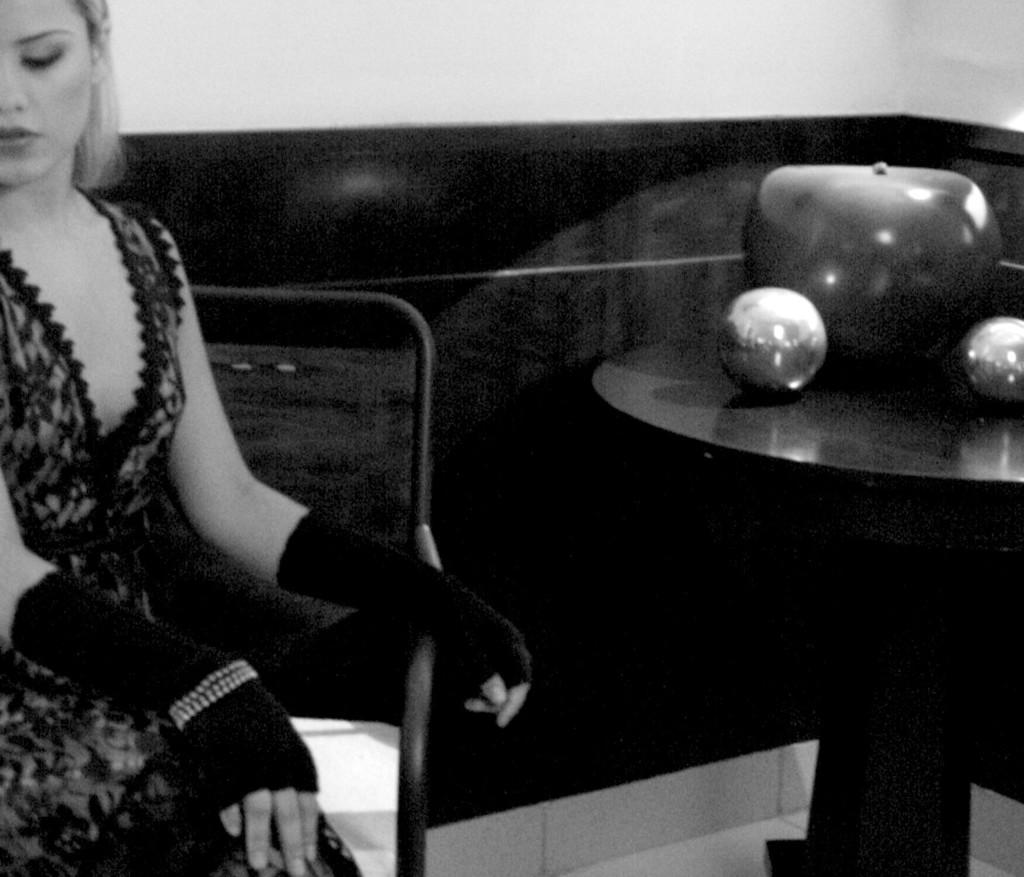Who is present in the image? There is a woman in the image. What is the woman doing in the image? The woman is sitting on a chair. What can be seen in the image besides the woman? There is a table in the image. What is on the table in the image? There are items on the table. What is visible in the background of the image? There is a wall in the background of the image. What type of engine can be seen in the image? There is no engine present in the image. Is there a gun visible on the table in the image? No, there is no gun visible in the image. 